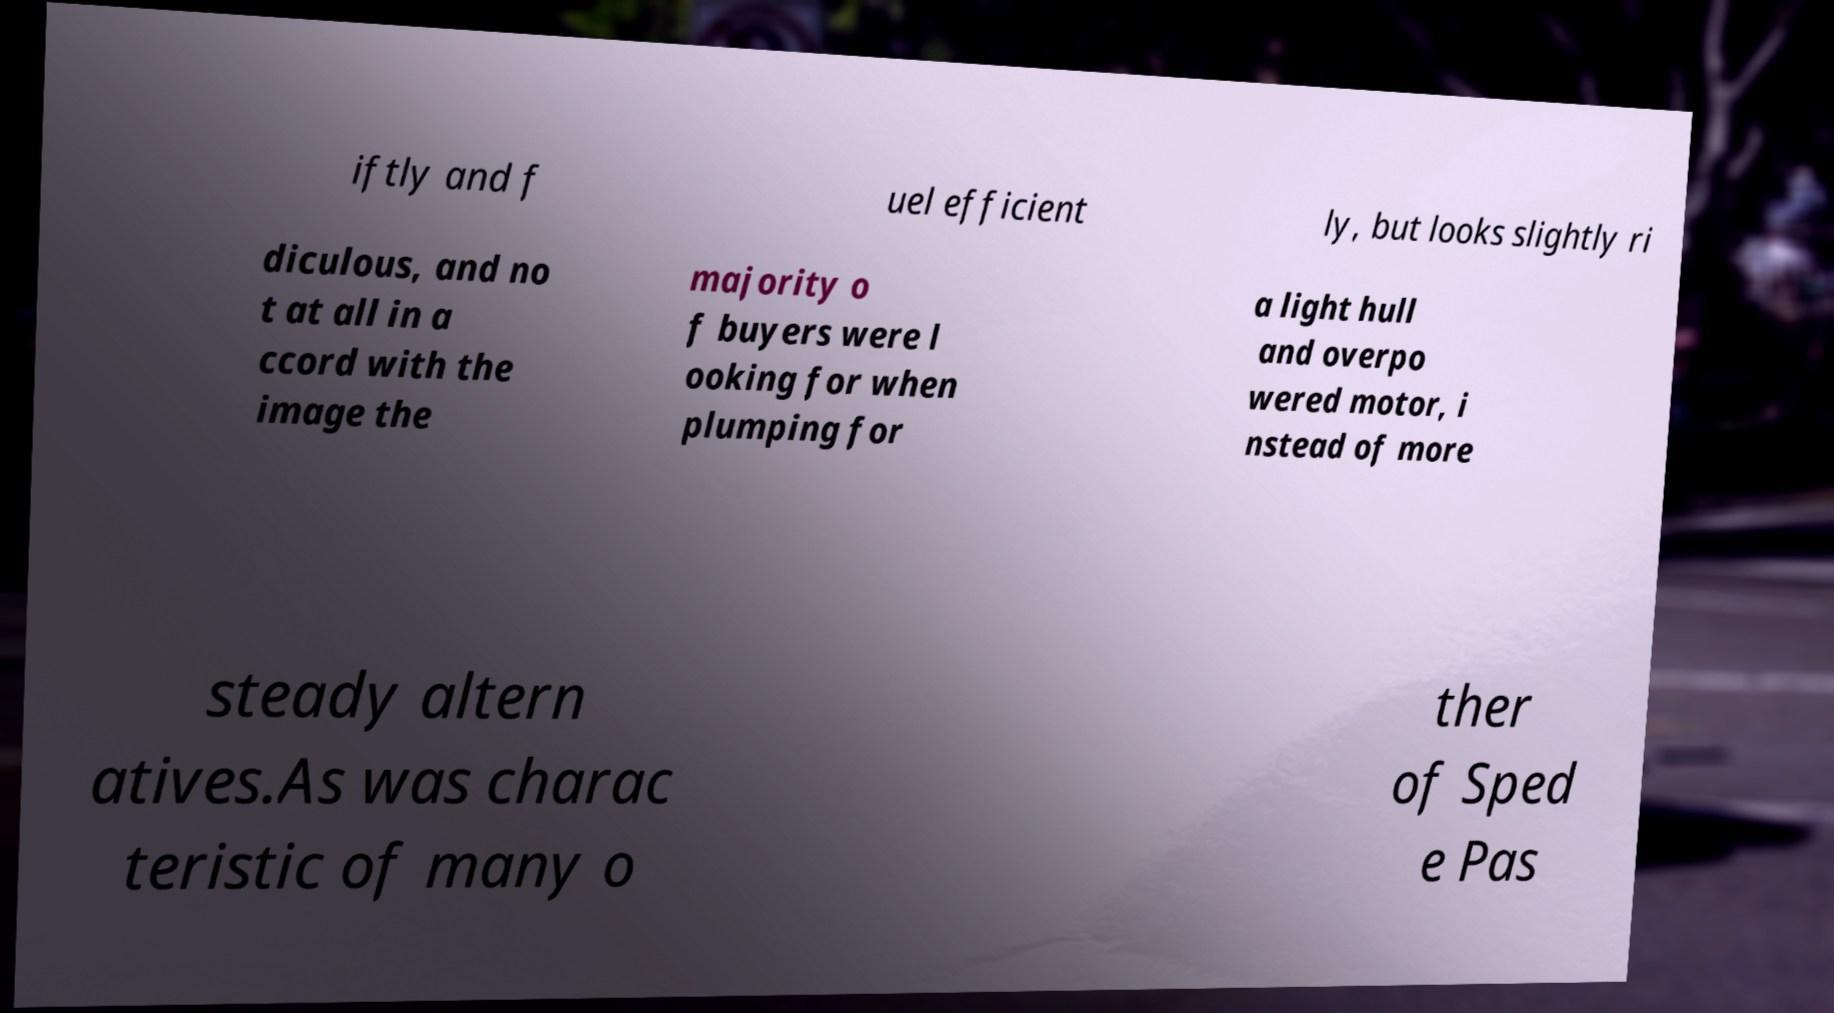Could you extract and type out the text from this image? iftly and f uel efficient ly, but looks slightly ri diculous, and no t at all in a ccord with the image the majority o f buyers were l ooking for when plumping for a light hull and overpo wered motor, i nstead of more steady altern atives.As was charac teristic of many o ther of Sped e Pas 